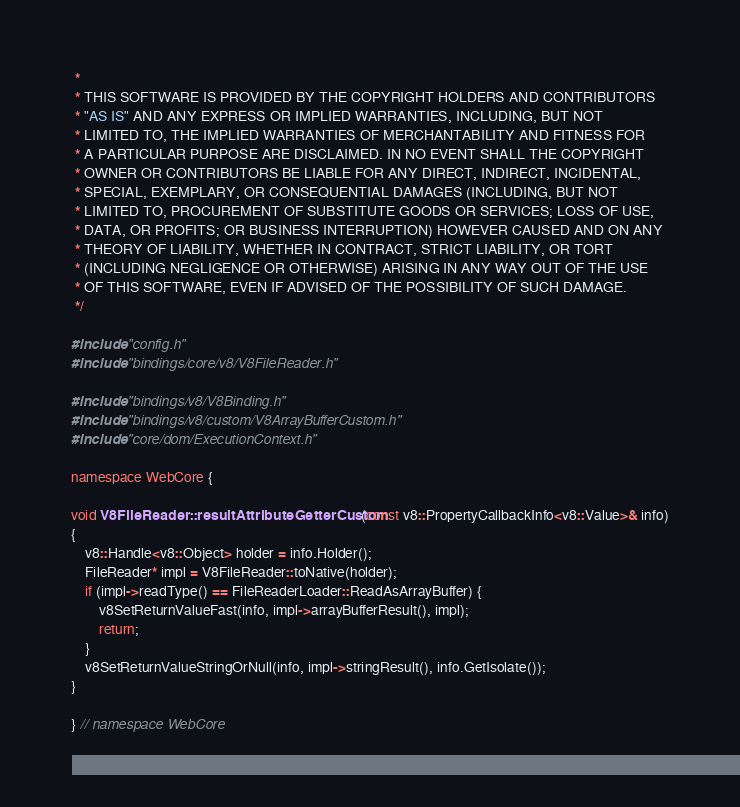<code> <loc_0><loc_0><loc_500><loc_500><_C++_> *
 * THIS SOFTWARE IS PROVIDED BY THE COPYRIGHT HOLDERS AND CONTRIBUTORS
 * "AS IS" AND ANY EXPRESS OR IMPLIED WARRANTIES, INCLUDING, BUT NOT
 * LIMITED TO, THE IMPLIED WARRANTIES OF MERCHANTABILITY AND FITNESS FOR
 * A PARTICULAR PURPOSE ARE DISCLAIMED. IN NO EVENT SHALL THE COPYRIGHT
 * OWNER OR CONTRIBUTORS BE LIABLE FOR ANY DIRECT, INDIRECT, INCIDENTAL,
 * SPECIAL, EXEMPLARY, OR CONSEQUENTIAL DAMAGES (INCLUDING, BUT NOT
 * LIMITED TO, PROCUREMENT OF SUBSTITUTE GOODS OR SERVICES; LOSS OF USE,
 * DATA, OR PROFITS; OR BUSINESS INTERRUPTION) HOWEVER CAUSED AND ON ANY
 * THEORY OF LIABILITY, WHETHER IN CONTRACT, STRICT LIABILITY, OR TORT
 * (INCLUDING NEGLIGENCE OR OTHERWISE) ARISING IN ANY WAY OUT OF THE USE
 * OF THIS SOFTWARE, EVEN IF ADVISED OF THE POSSIBILITY OF SUCH DAMAGE.
 */

#include "config.h"
#include "bindings/core/v8/V8FileReader.h"

#include "bindings/v8/V8Binding.h"
#include "bindings/v8/custom/V8ArrayBufferCustom.h"
#include "core/dom/ExecutionContext.h"

namespace WebCore {

void V8FileReader::resultAttributeGetterCustom(const v8::PropertyCallbackInfo<v8::Value>& info)
{
    v8::Handle<v8::Object> holder = info.Holder();
    FileReader* impl = V8FileReader::toNative(holder);
    if (impl->readType() == FileReaderLoader::ReadAsArrayBuffer) {
        v8SetReturnValueFast(info, impl->arrayBufferResult(), impl);
        return;
    }
    v8SetReturnValueStringOrNull(info, impl->stringResult(), info.GetIsolate());
}

} // namespace WebCore
</code> 